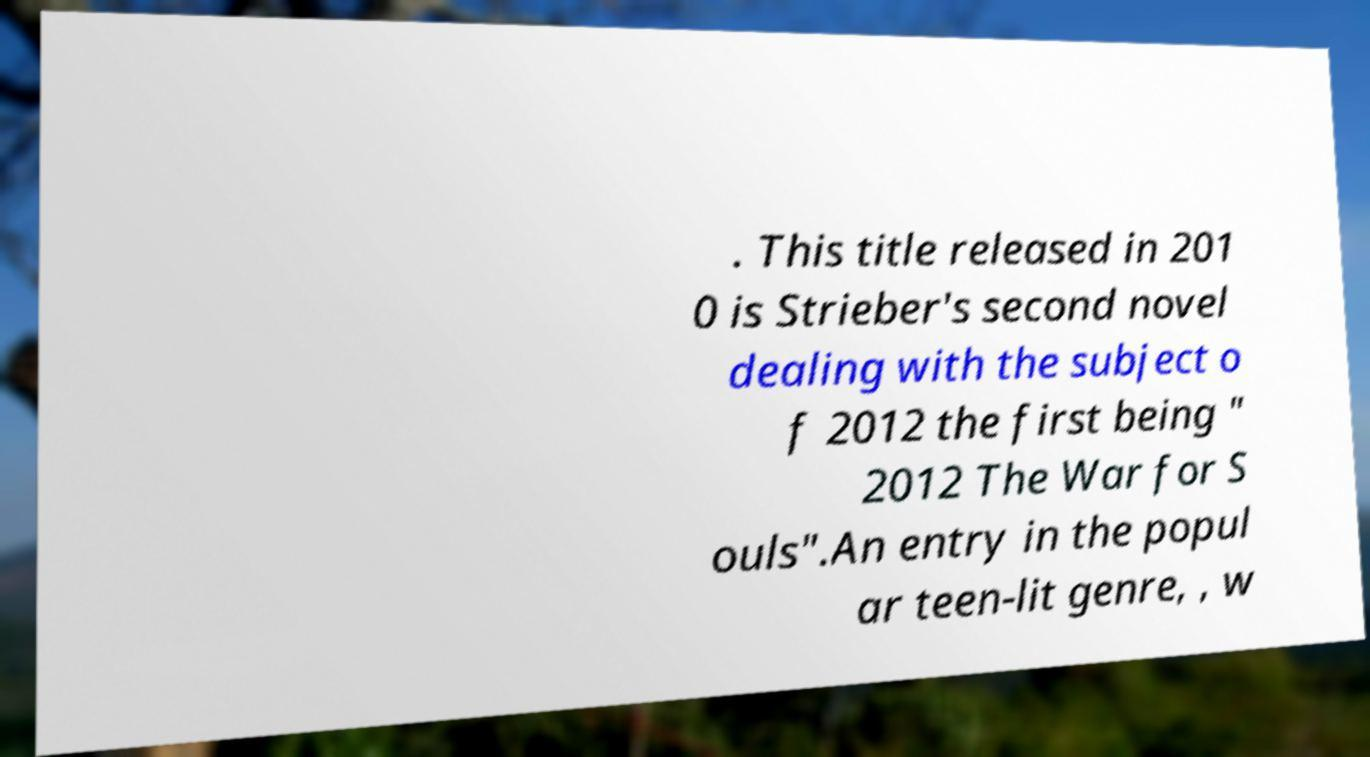Please identify and transcribe the text found in this image. . This title released in 201 0 is Strieber's second novel dealing with the subject o f 2012 the first being " 2012 The War for S ouls".An entry in the popul ar teen-lit genre, , w 